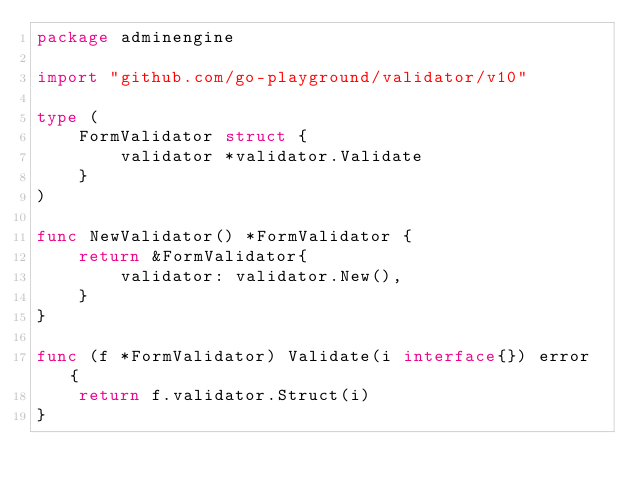Convert code to text. <code><loc_0><loc_0><loc_500><loc_500><_Go_>package adminengine

import "github.com/go-playground/validator/v10"

type (
	FormValidator struct {
		validator *validator.Validate
	}
)

func NewValidator() *FormValidator {
	return &FormValidator{
		validator: validator.New(),
	}
}

func (f *FormValidator) Validate(i interface{}) error {
	return f.validator.Struct(i)
}
</code> 